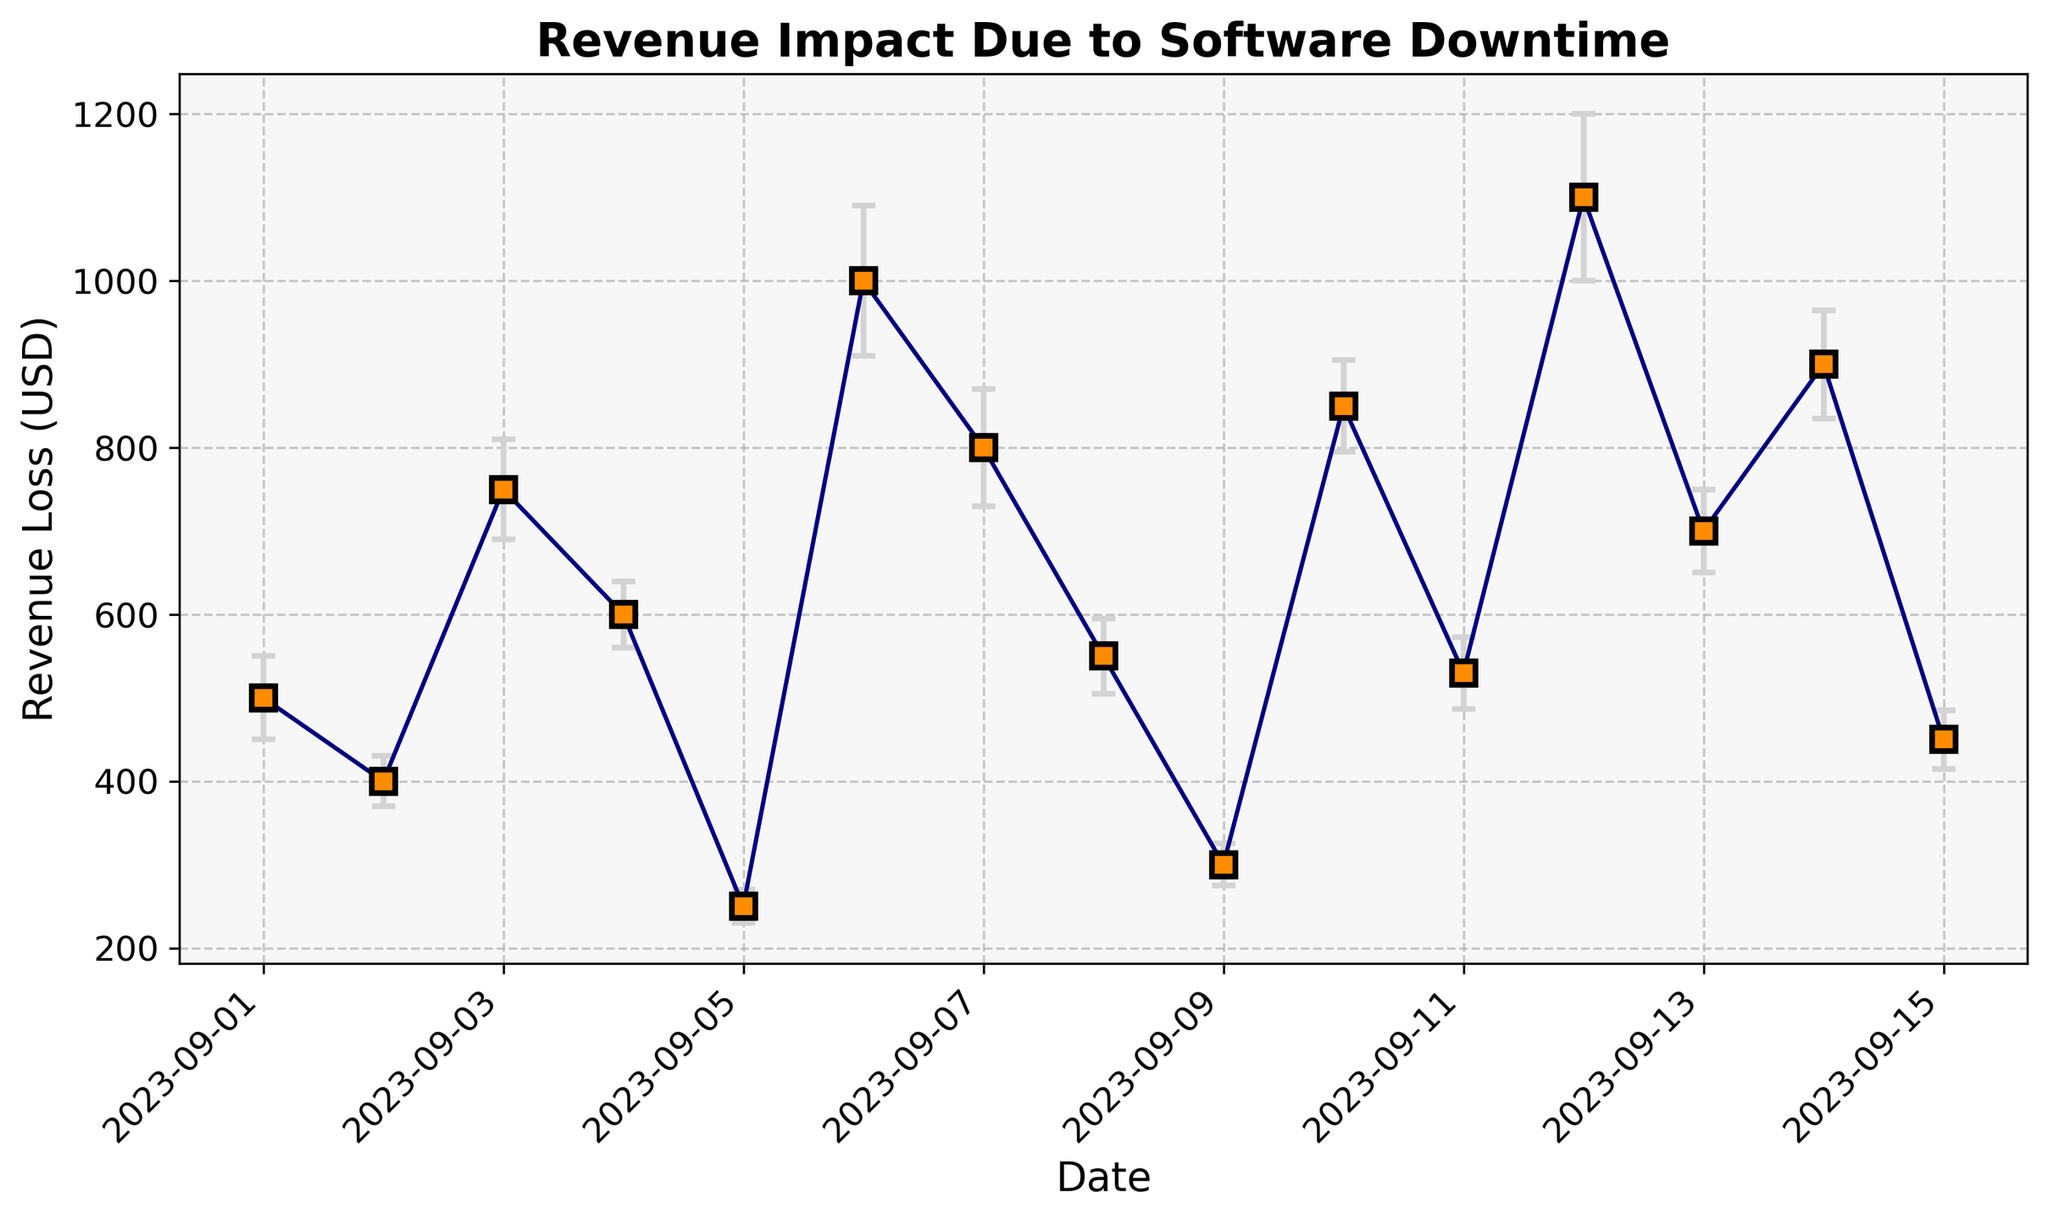What is the total revenue loss on September 6th plus the error estimate? To find the total revenue loss plus the error for September 6th, locate the data for that date: Revenue Loss = $1000 and Error = $90. Add them together to get $1000 + $90.
Answer: $1090 On which date did we experience the highest revenue loss due to downtime? The highest revenue loss value in the dataset is $1100. Locate this value in the chart to find the corresponding date, which is September 12th.
Answer: September 12th What is the difference in revenue loss between September 3rd and September 9th? Find the revenue loss for September 3rd, which is $750, and for September 9th, which is $300. Subtract the smaller loss from the larger loss: $750 - $300.
Answer: $450 Which day had the least revenue loss, and what was its error estimate? The least revenue loss is $250. Locate this value in the chart to find the corresponding date (September 5th) and note the error estimate, which is $20.
Answer: September 5th, $20 Did any date with 4 or more hours of downtime have a revenue loss of less than $1000? Identify the dates with 4 or more hours of downtime: September 6th and September 12th ($1000 and $1100 respectively). Both values are not less than $1000.
Answer: No How many dates had a revenue loss within the error margin of ±70? Identify dates where the error is ±70 or less: Sept 1, 2, 3, 4, 5, 6, 7, 8, 9, 10, 11, 13, 14, and 15. Count them:
Answer: 14 Does a higher downtime duration always correlate with a higher revenue loss? Compare the downtime hours and revenue loss values. Note cases like Sept 6th (4hrs, $1000) vs. Sept 12th (4.5hrs, $1100) vs. Sept 13th (2.5hrs, $700). Not always as evident in examples like Sept 4th (2.5hrs, $600) vs. Sept 13th (2.5hrs, $700).
Answer: No What is the average revenue loss for dates with downtime of 2 hours? Extract revenue losses for dates with 2-hour downtimes: Sept 1 ($500), Sept 8 ($550), and Sept 11 ($530). Calculate the average: ($500 + $550 + $530) / 3.
Answer: $527 On which date did the revenue loss come with the highest error estimate, and what was the error value? The highest error estimate is $100. Locate this value in the chart to find the corresponding date, which is September 12th.
Answer: September 12th, $100 